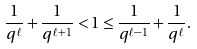<formula> <loc_0><loc_0><loc_500><loc_500>\frac { 1 } { q ^ { \ell } } + \frac { 1 } { q ^ { \ell + 1 } } < 1 \leq \frac { 1 } { q ^ { \ell - 1 } } + \frac { 1 } { q ^ { \ell } } .</formula> 